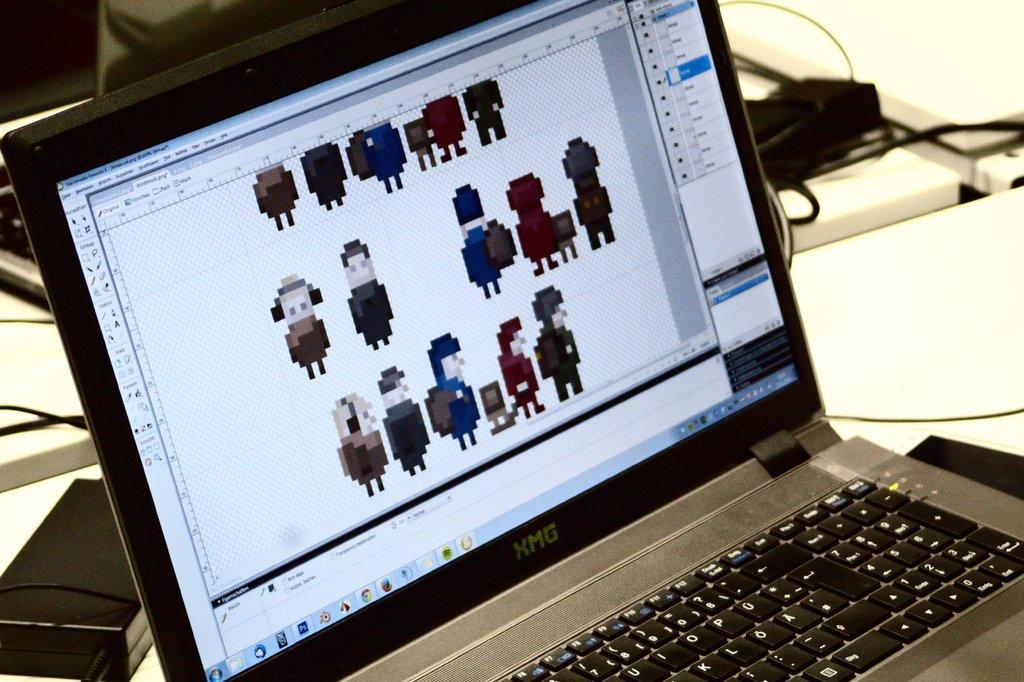What is the brand of the laptop?
Make the answer very short. Xmg. 